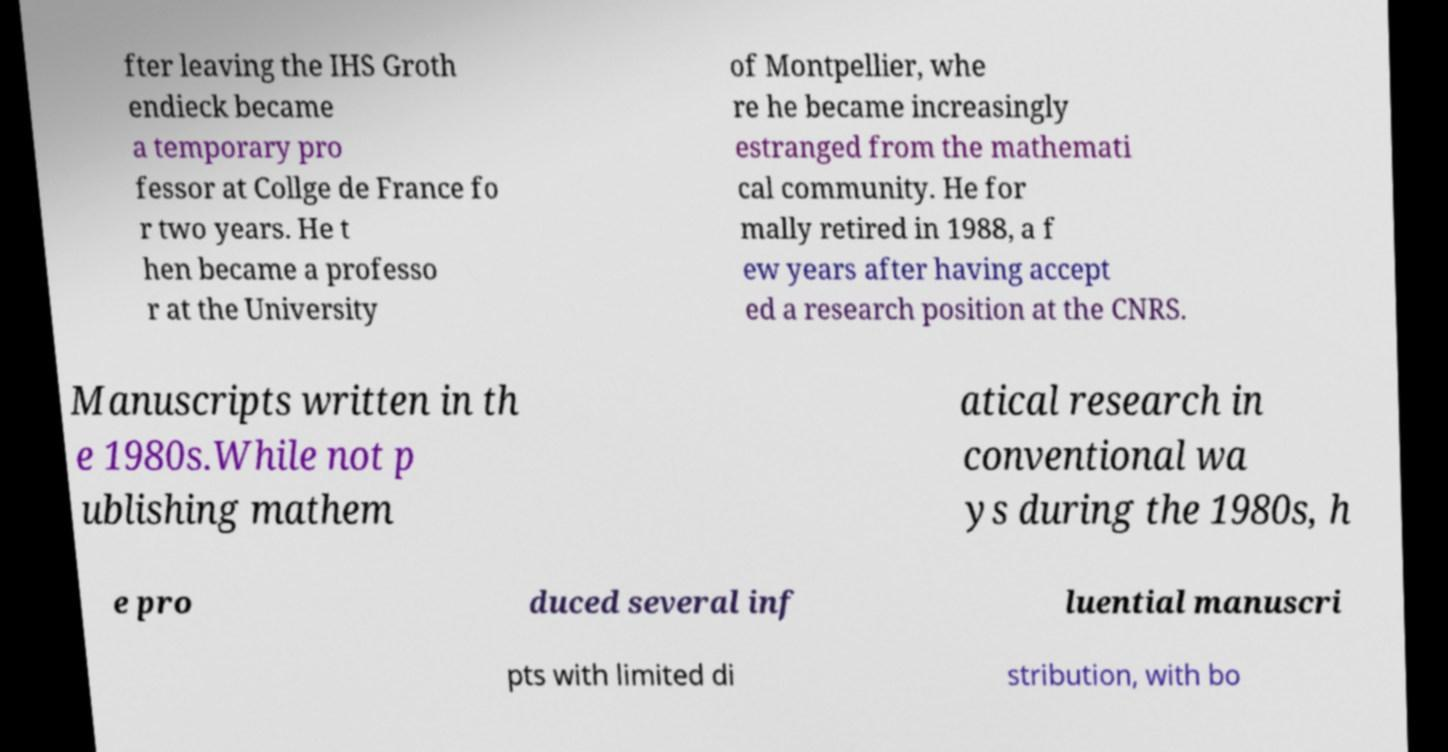Could you extract and type out the text from this image? fter leaving the IHS Groth endieck became a temporary pro fessor at Collge de France fo r two years. He t hen became a professo r at the University of Montpellier, whe re he became increasingly estranged from the mathemati cal community. He for mally retired in 1988, a f ew years after having accept ed a research position at the CNRS. Manuscripts written in th e 1980s.While not p ublishing mathem atical research in conventional wa ys during the 1980s, h e pro duced several inf luential manuscri pts with limited di stribution, with bo 